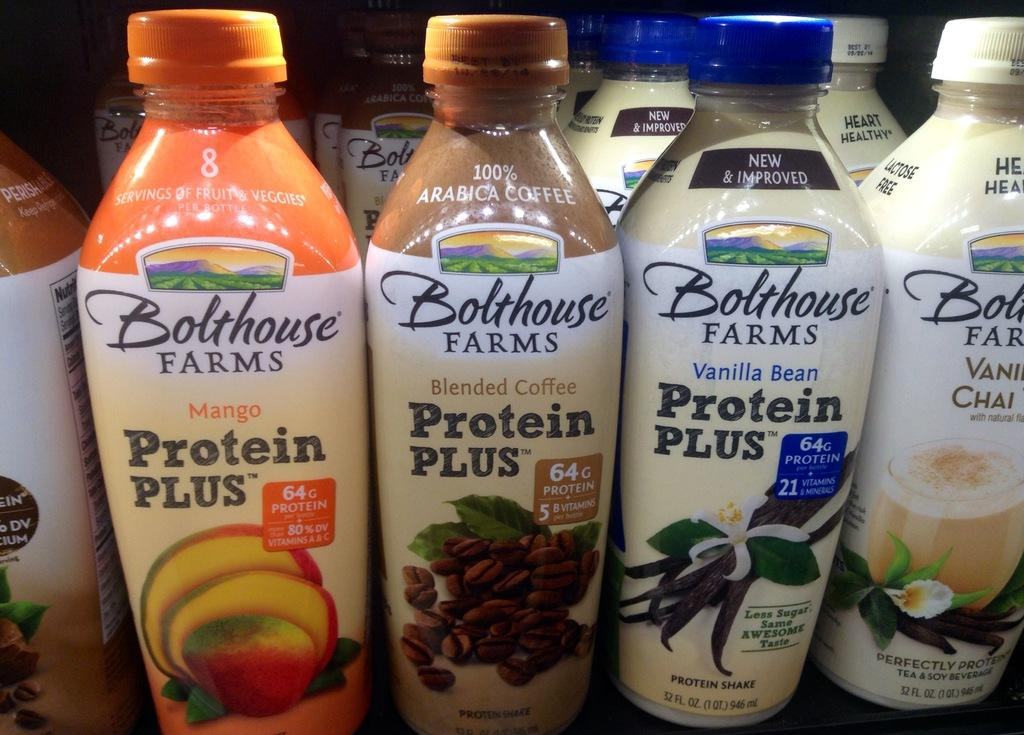What objects can be seen in the image? There are bottles in the image. What type of marble is being used to play a game in the image? There is no marble or game present in the image; it only features bottles. How does the grass appear in the image? There is no grass present in the image; it only features bottles. 